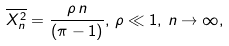Convert formula to latex. <formula><loc_0><loc_0><loc_500><loc_500>\overline { { X } _ { n } ^ { 2 } } = \frac { \rho \, n } { ( \pi - 1 ) } , \, \rho \ll 1 , \, n \to \infty ,</formula> 